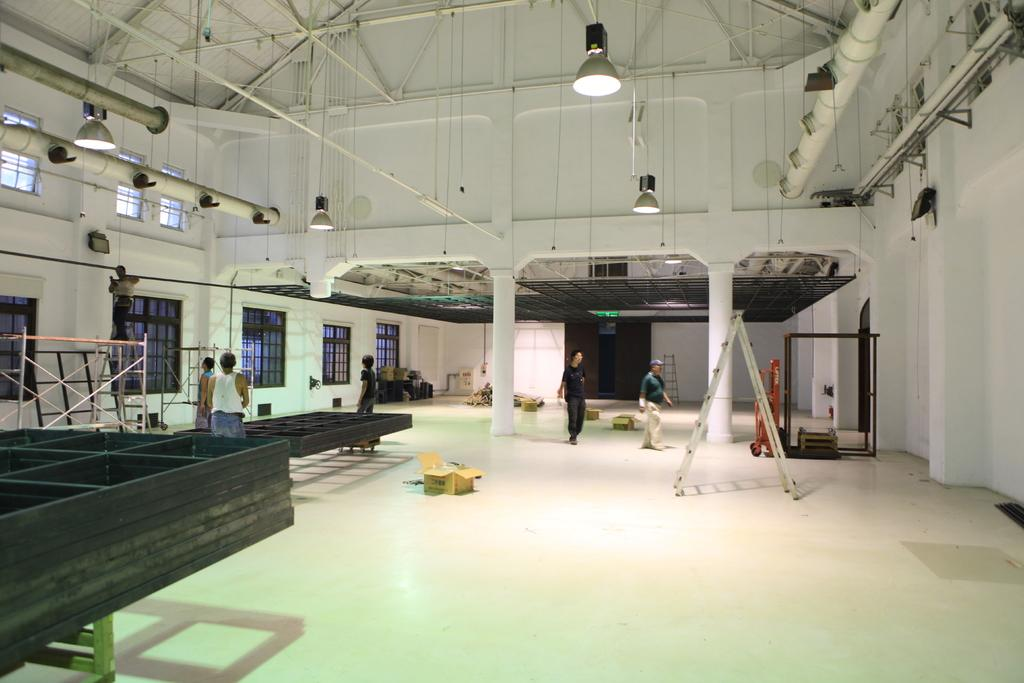How many people can be seen in the image? There are people in the image, but the exact number is not specified. What object is used for climbing in the image? There is a ladder in the image. What type of containers are present in the image? Cardboard boxes are present in the image. What is on the floor in the image? There are objects on the floor. What type of architectural feature is present in the image? There are pillars in the image. What can be seen through the windows in the image? Windows are visible in the image, but the view through them is not specified. What type of lighting is present in the image? Lights are present at the top of the image. What type of structural element is present at the top of the image? Rods are present at the top of the image. How many rabbits are hopping around in the image? There are no rabbits present in the image. What type of stew is being prepared in the image? There is no stew being prepared in the image. 